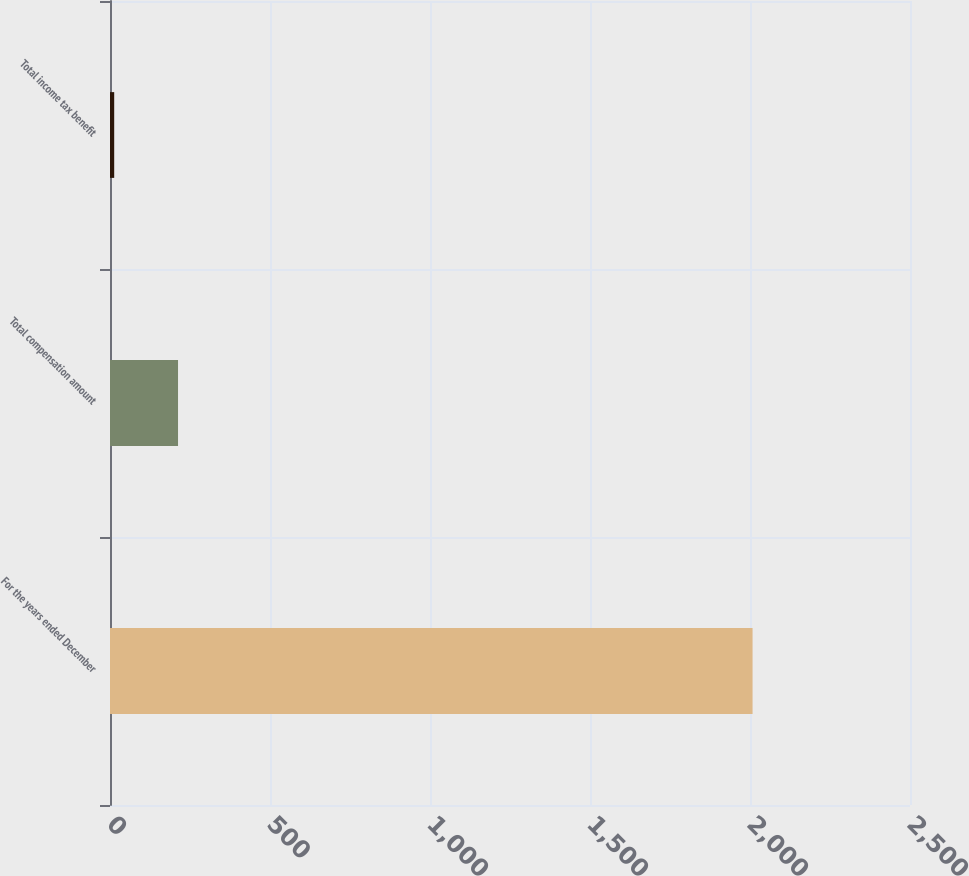Convert chart. <chart><loc_0><loc_0><loc_500><loc_500><bar_chart><fcel>For the years ended December<fcel>Total compensation amount<fcel>Total income tax benefit<nl><fcel>2008<fcel>212.59<fcel>13.1<nl></chart> 